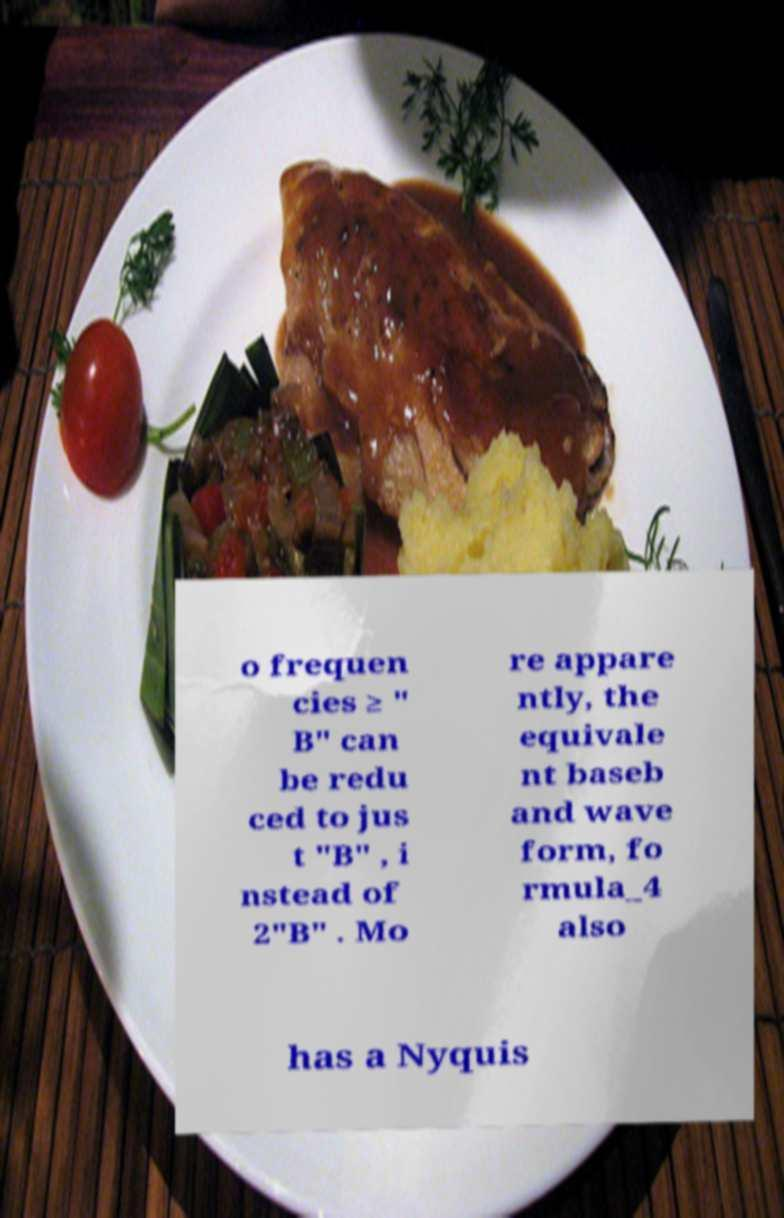I need the written content from this picture converted into text. Can you do that? o frequen cies ≥ " B" can be redu ced to jus t "B" , i nstead of 2"B" . Mo re appare ntly, the equivale nt baseb and wave form, fo rmula_4 also has a Nyquis 